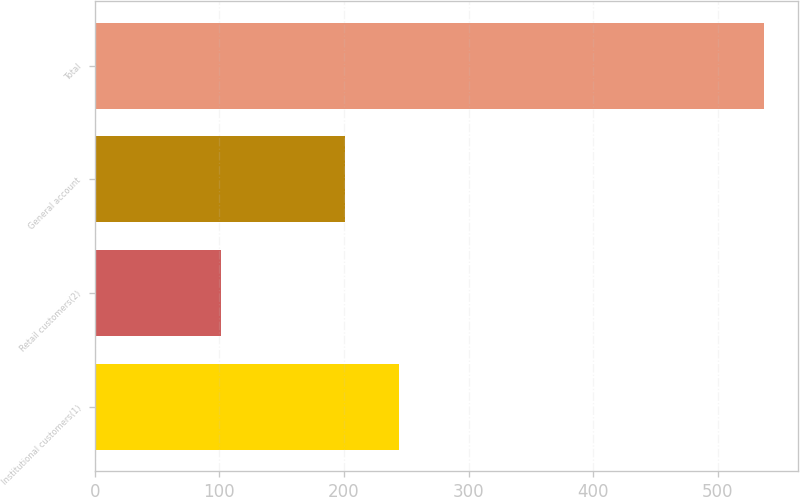<chart> <loc_0><loc_0><loc_500><loc_500><bar_chart><fcel>Institutional customers(1)<fcel>Retail customers(2)<fcel>General account<fcel>Total<nl><fcel>244.41<fcel>101.2<fcel>200.8<fcel>537.3<nl></chart> 